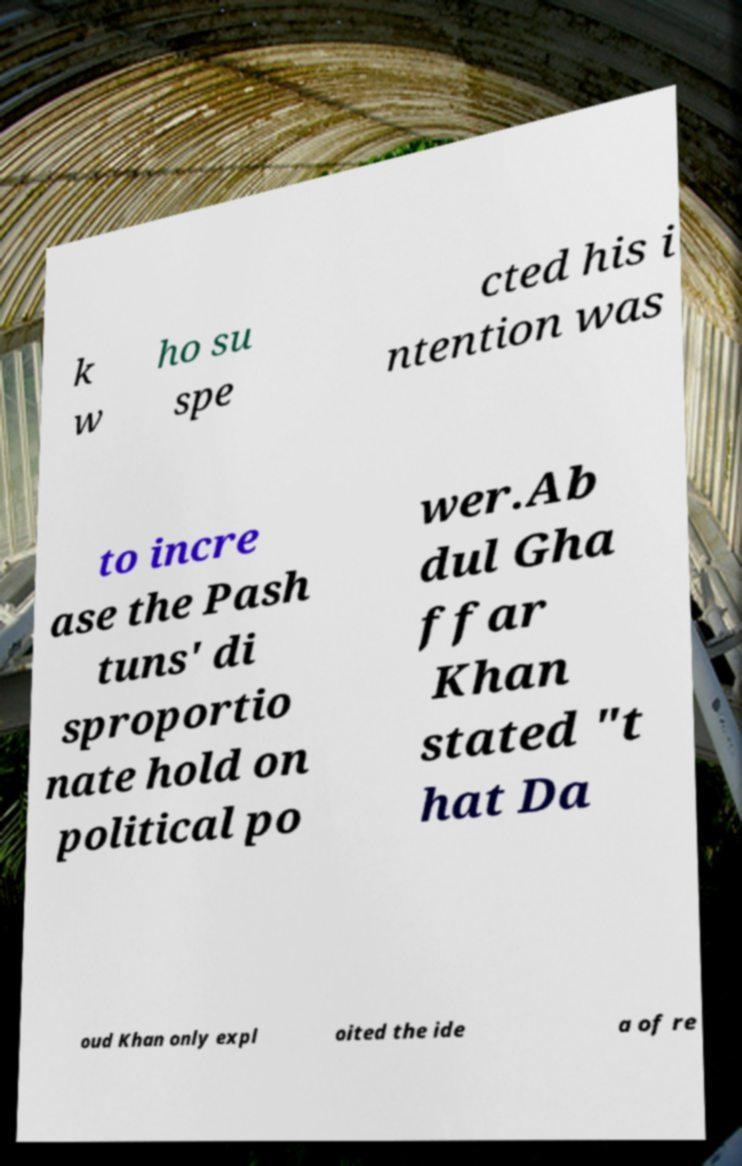I need the written content from this picture converted into text. Can you do that? k w ho su spe cted his i ntention was to incre ase the Pash tuns' di sproportio nate hold on political po wer.Ab dul Gha ffar Khan stated "t hat Da oud Khan only expl oited the ide a of re 